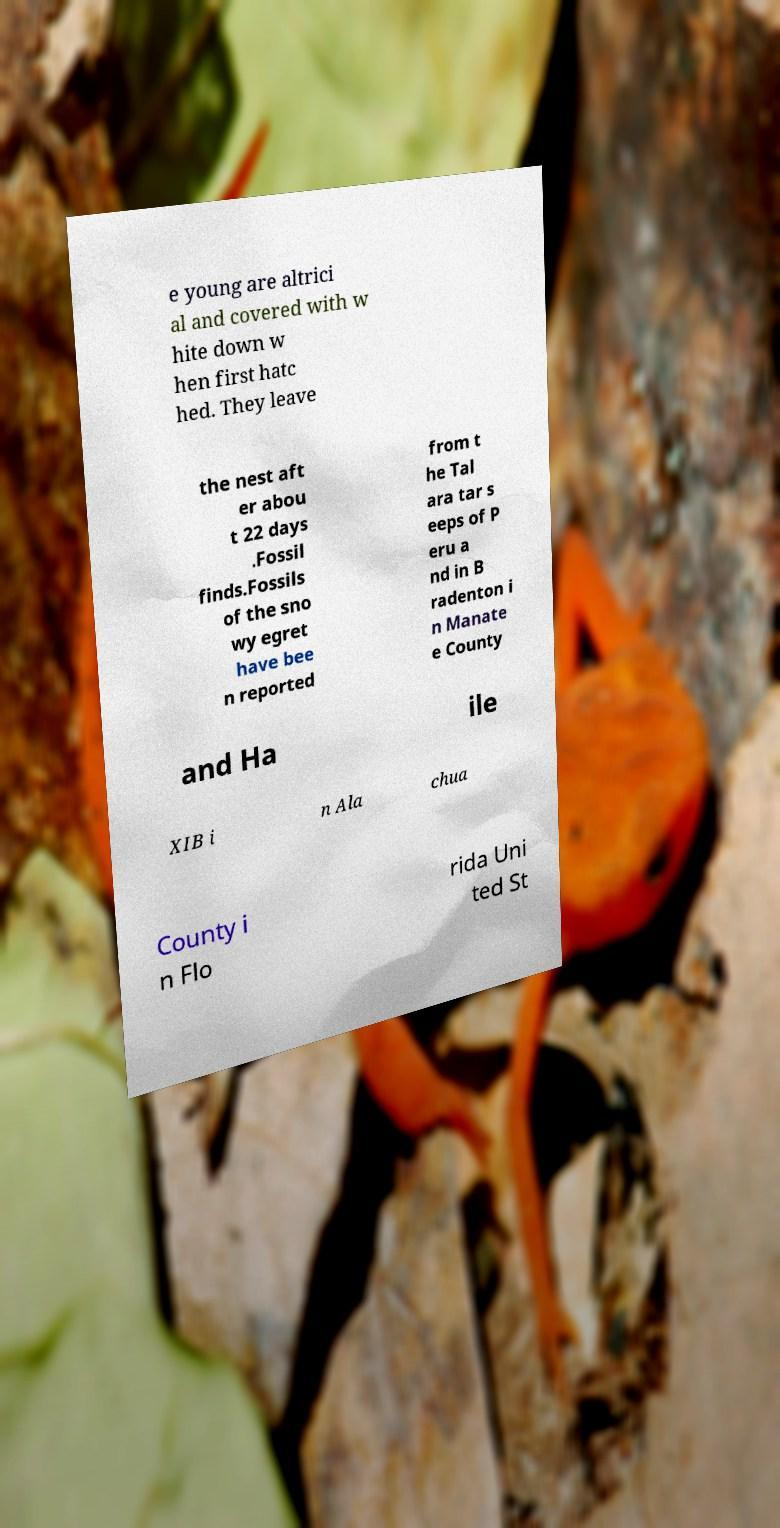What messages or text are displayed in this image? I need them in a readable, typed format. e young are altrici al and covered with w hite down w hen first hatc hed. They leave the nest aft er abou t 22 days .Fossil finds.Fossils of the sno wy egret have bee n reported from t he Tal ara tar s eeps of P eru a nd in B radenton i n Manate e County and Ha ile XIB i n Ala chua County i n Flo rida Uni ted St 